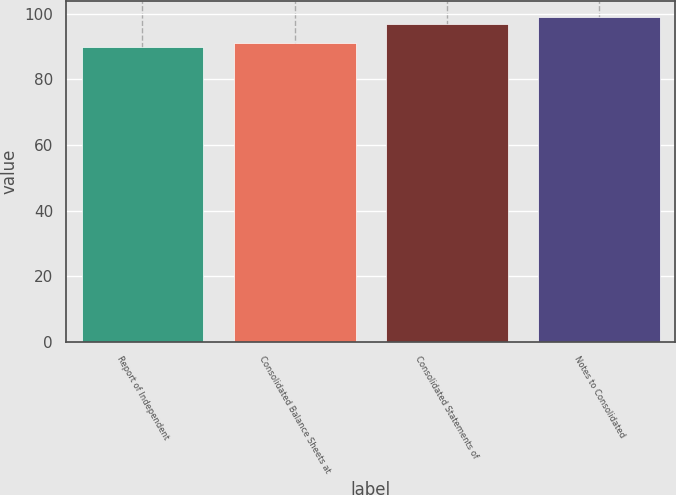Convert chart to OTSL. <chart><loc_0><loc_0><loc_500><loc_500><bar_chart><fcel>Report of Independent<fcel>Consolidated Balance Sheets at<fcel>Consolidated Statements of<fcel>Notes to Consolidated<nl><fcel>90<fcel>91<fcel>97<fcel>99<nl></chart> 